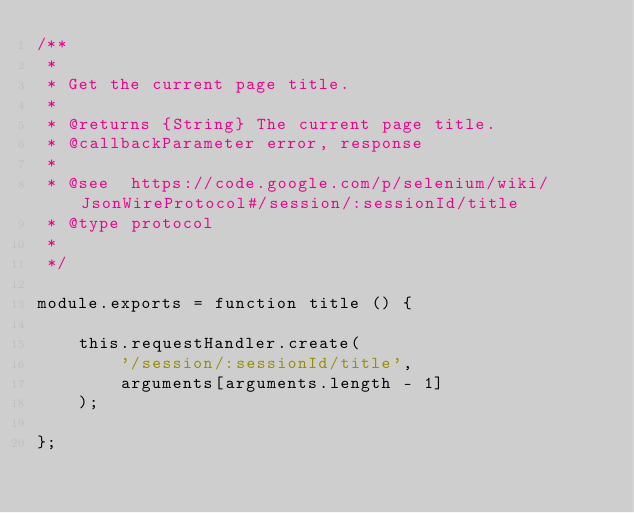Convert code to text. <code><loc_0><loc_0><loc_500><loc_500><_JavaScript_>/**
 *
 * Get the current page title.
 *
 * @returns {String} The current page title.
 * @callbackParameter error, response
 *
 * @see  https://code.google.com/p/selenium/wiki/JsonWireProtocol#/session/:sessionId/title
 * @type protocol
 *
 */

module.exports = function title () {

    this.requestHandler.create(
        '/session/:sessionId/title',
        arguments[arguments.length - 1]
    );

};</code> 